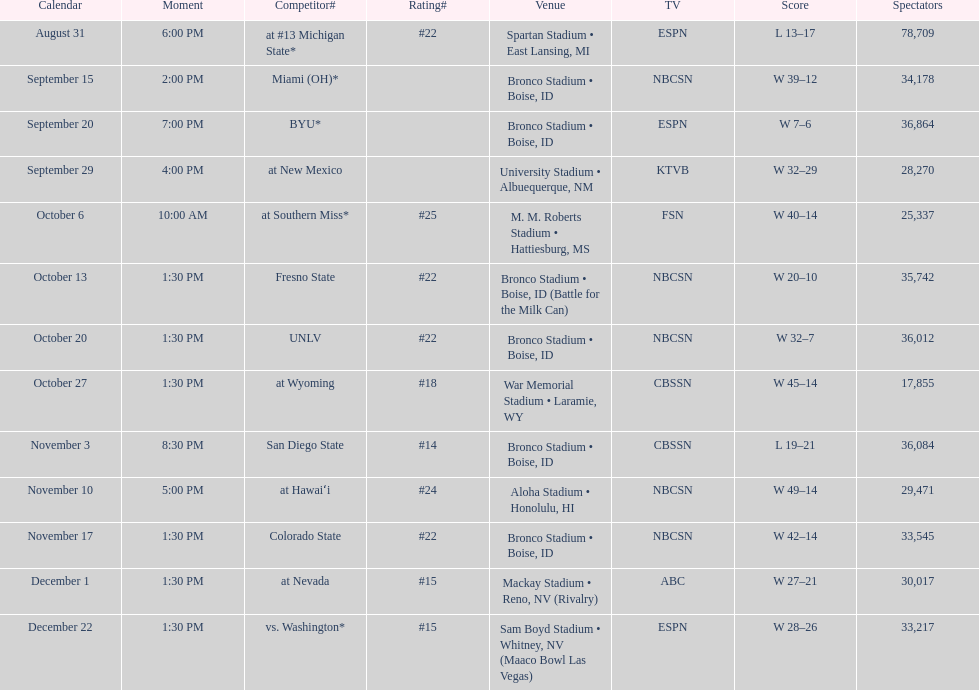What was there top ranked position of the season? #14. 